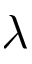Convert formula to latex. <formula><loc_0><loc_0><loc_500><loc_500>\lambda</formula> 